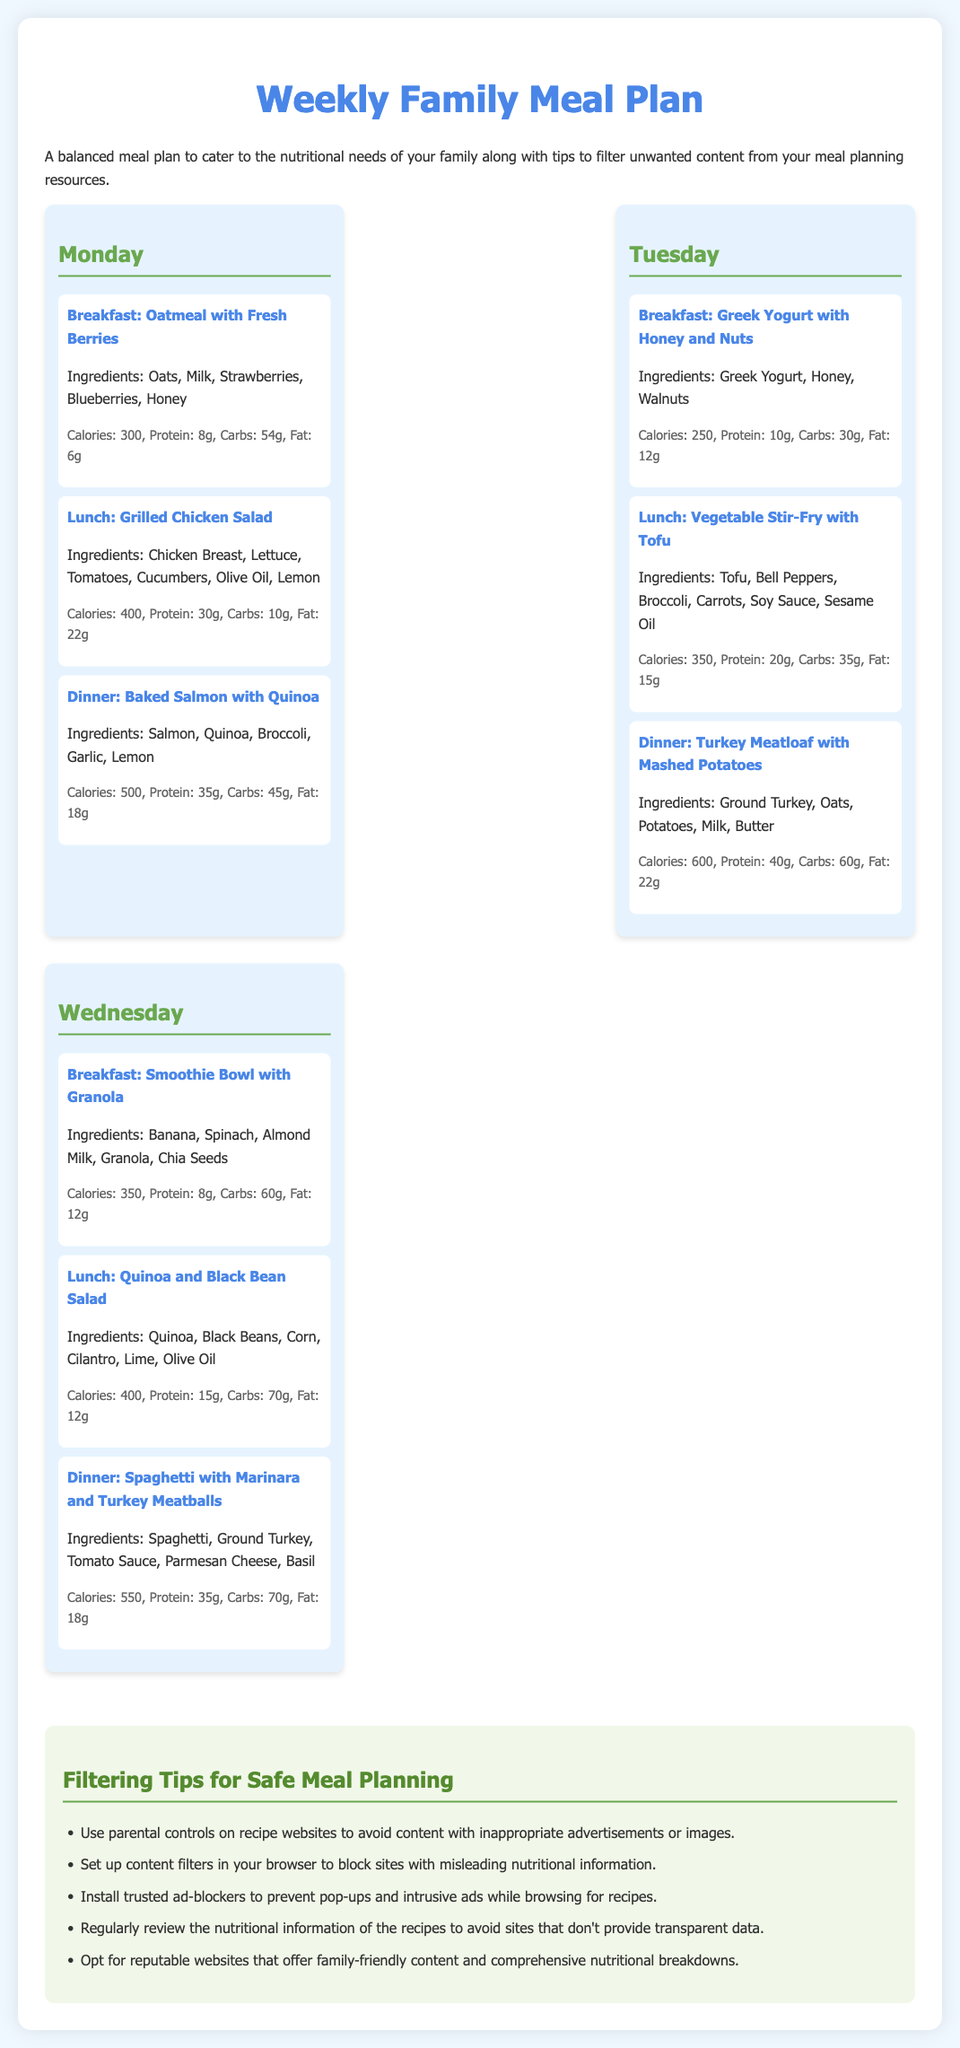What is the calorie count for breakfast on Monday? The calorie count for breakfast on Monday (Oatmeal with Fresh Berries) is explicitly stated in the document.
Answer: 300 How many grams of protein does the Tuesday lunch provide? The protein amount for the Tuesday lunch (Vegetable Stir-Fry with Tofu) is listed in the nutritional information section.
Answer: 20g What is a recommended filtering tip mentioned in the document? The document offers tips for filtering content, one of which is specifically highlighted.
Answer: Use parental controls on recipe websites Which day features a dinner that includes salmon? The document has specific meals listed for each day, and salmon is noted in the dinner meal for a certain day.
Answer: Monday What is the total number of meals planned for Wednesday? The document outlines three meals for Wednesday specifically; thus, the total can be easily counted.
Answer: 3 What is the main ingredient in the breakfast for Tuesday? The document lists the ingredients for Tuesday's breakfast, highlighting the main component.
Answer: Greek Yogurt How many grams of carbohydrates are in the dinner for Tuesday? The carbohydrate content in the Tuesday dinner (Turkey Meatloaf with Mashed Potatoes) is mentioned in the nutritional information.
Answer: 60g What type of cuisine is represented by the meal "Spaghetti with Marinara and Turkey Meatballs"? The meal is identified in the document and can be categorized by its main components.
Answer: Italian What color is used for the headings of the meals? The document visually describes the styling of headings within the meal sections.
Answer: Blue 